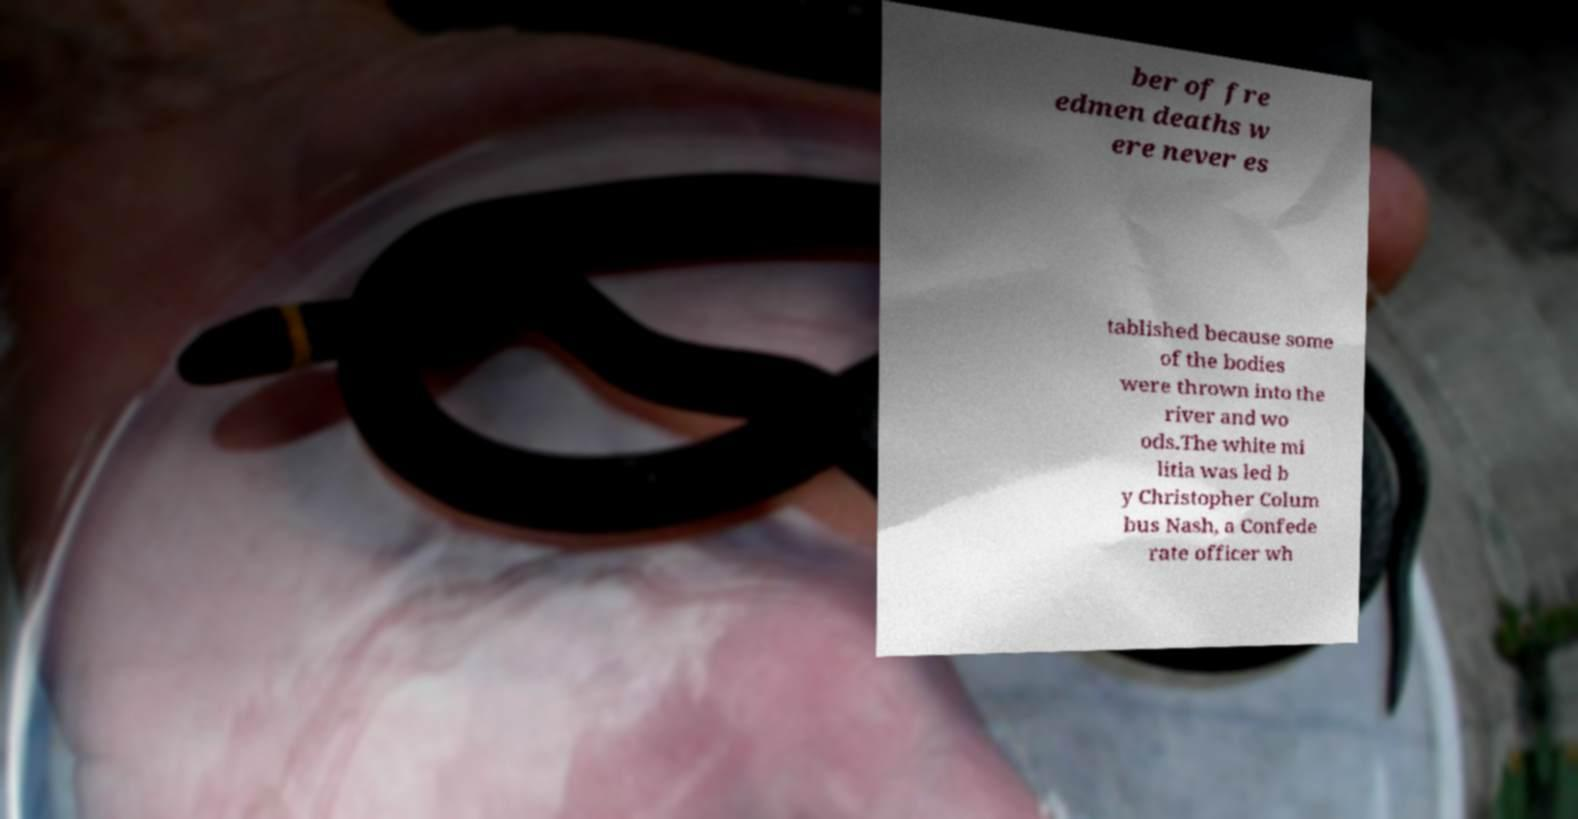I need the written content from this picture converted into text. Can you do that? ber of fre edmen deaths w ere never es tablished because some of the bodies were thrown into the river and wo ods.The white mi litia was led b y Christopher Colum bus Nash, a Confede rate officer wh 